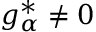<formula> <loc_0><loc_0><loc_500><loc_500>g _ { \alpha } ^ { * } \neq 0</formula> 